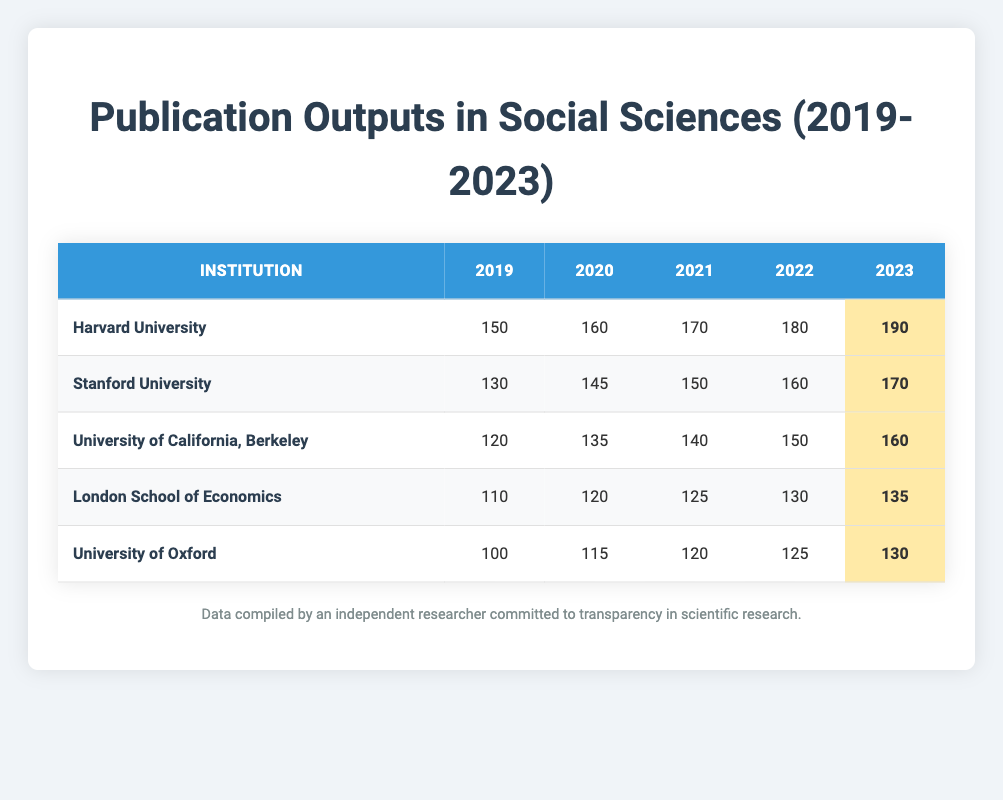What institution had the highest publication output in 2023? Looking at the 2023 data in the table, Harvard University had 190 publications, which is higher than the outputs of all other institutions listed.
Answer: Harvard University How many publications did Stanford University produce in 2021? By checking the row for Stanford University under the year 2021, we see that the value is 150 publications.
Answer: 150 What was the change in publication output for the University of California, Berkeley from 2019 to 2022? In 2019, the University of California, Berkeley had 120 publications, and in 2022 it increased to 150. The change can be calculated as 150 - 120 = 30.
Answer: 30 Is the total publication output of the London School of Economics from 2019 to 2023 greater than that of the University of Oxford in the same period? Adding the publications of the London School of Economics: 110 + 120 + 125 + 130 + 135 = 620. For the University of Oxford: 100 + 115 + 120 + 125 + 130 = 590. Since 620 > 590, the statement is true.
Answer: Yes Which institution showed the largest year-over-year increase in publication output from 2022 to 2023? Comparing the outputs for each institution from 2022 to 2023: Harvard University increased by 10 (190 - 180), Stanford University by 10 (170 - 160), University of California, Berkeley by 10 (160 - 150), London School of Economics by 5 (135 - 130), and University of Oxford by 5 (130 - 125). The top institutions all had the same increase of 10, making them tied for the largest increase.
Answer: Harvard University, Stanford University, University of California, Berkeley What was the average number of publications for Stanford University over the five years? The publication outputs for Stanford University from 2019 to 2023 are: 130, 145, 150, 160, and 170. The sum is 130 + 145 + 150 + 160 + 170 = 755. Then, dividing by the 5 years gives an average of 755 / 5 = 151.
Answer: 151 